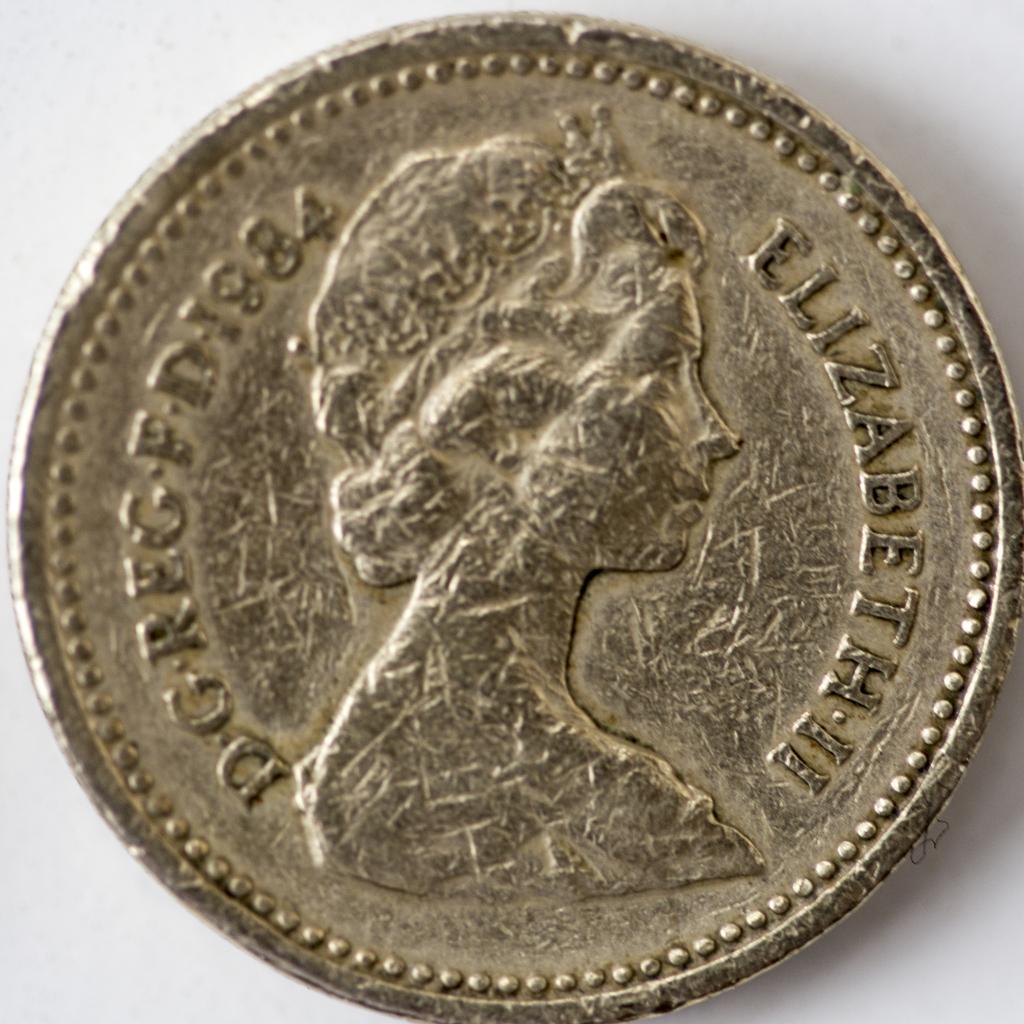What year is on the coin?
Give a very brief answer. 1984. 